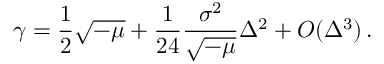Convert formula to latex. <formula><loc_0><loc_0><loc_500><loc_500>\gamma = \frac { 1 } { 2 } \sqrt { - \mu } + \frac { 1 } { 2 4 } \frac { \sigma ^ { 2 } } { \sqrt { - \mu } } \Delta ^ { 2 } + O ( \Delta ^ { 3 } ) \, .</formula> 